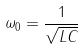Convert formula to latex. <formula><loc_0><loc_0><loc_500><loc_500>\omega _ { 0 } = \frac { 1 } { \sqrt { L C } }</formula> 